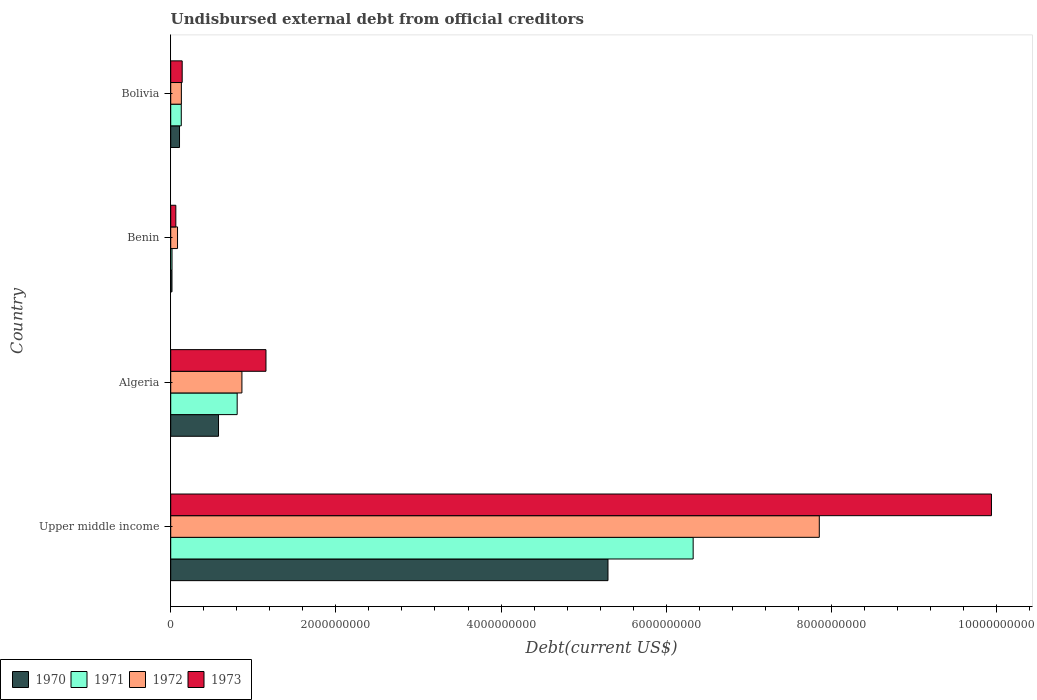Are the number of bars per tick equal to the number of legend labels?
Give a very brief answer. Yes. How many bars are there on the 4th tick from the top?
Provide a succinct answer. 4. How many bars are there on the 3rd tick from the bottom?
Offer a very short reply. 4. What is the total debt in 1973 in Benin?
Keep it short and to the point. 6.20e+07. Across all countries, what is the maximum total debt in 1970?
Provide a succinct answer. 5.30e+09. Across all countries, what is the minimum total debt in 1973?
Keep it short and to the point. 6.20e+07. In which country was the total debt in 1970 maximum?
Your answer should be very brief. Upper middle income. In which country was the total debt in 1972 minimum?
Provide a short and direct response. Benin. What is the total total debt in 1971 in the graph?
Your answer should be very brief. 7.28e+09. What is the difference between the total debt in 1971 in Benin and that in Bolivia?
Make the answer very short. -1.12e+08. What is the difference between the total debt in 1971 in Benin and the total debt in 1972 in Upper middle income?
Your answer should be very brief. -7.84e+09. What is the average total debt in 1972 per country?
Give a very brief answer. 2.23e+09. What is the difference between the total debt in 1971 and total debt in 1972 in Upper middle income?
Your answer should be very brief. -1.53e+09. What is the ratio of the total debt in 1973 in Algeria to that in Benin?
Provide a succinct answer. 18.61. Is the total debt in 1973 in Algeria less than that in Benin?
Provide a succinct answer. No. Is the difference between the total debt in 1971 in Benin and Bolivia greater than the difference between the total debt in 1972 in Benin and Bolivia?
Provide a short and direct response. No. What is the difference between the highest and the second highest total debt in 1973?
Your response must be concise. 8.79e+09. What is the difference between the highest and the lowest total debt in 1973?
Make the answer very short. 9.88e+09. What does the 2nd bar from the top in Bolivia represents?
Ensure brevity in your answer.  1972. What does the 2nd bar from the bottom in Benin represents?
Provide a succinct answer. 1971. Are all the bars in the graph horizontal?
Offer a terse response. Yes. Does the graph contain grids?
Keep it short and to the point. No. Where does the legend appear in the graph?
Your answer should be very brief. Bottom left. What is the title of the graph?
Give a very brief answer. Undisbursed external debt from official creditors. What is the label or title of the X-axis?
Offer a terse response. Debt(current US$). What is the Debt(current US$) in 1970 in Upper middle income?
Offer a terse response. 5.30e+09. What is the Debt(current US$) of 1971 in Upper middle income?
Your response must be concise. 6.33e+09. What is the Debt(current US$) in 1972 in Upper middle income?
Ensure brevity in your answer.  7.85e+09. What is the Debt(current US$) in 1973 in Upper middle income?
Make the answer very short. 9.94e+09. What is the Debt(current US$) of 1970 in Algeria?
Provide a short and direct response. 5.79e+08. What is the Debt(current US$) in 1971 in Algeria?
Your answer should be compact. 8.05e+08. What is the Debt(current US$) of 1972 in Algeria?
Make the answer very short. 8.62e+08. What is the Debt(current US$) in 1973 in Algeria?
Make the answer very short. 1.15e+09. What is the Debt(current US$) of 1970 in Benin?
Your response must be concise. 1.53e+07. What is the Debt(current US$) of 1971 in Benin?
Your answer should be very brief. 1.57e+07. What is the Debt(current US$) of 1972 in Benin?
Offer a terse response. 8.25e+07. What is the Debt(current US$) in 1973 in Benin?
Your answer should be compact. 6.20e+07. What is the Debt(current US$) of 1970 in Bolivia?
Your answer should be very brief. 1.07e+08. What is the Debt(current US$) of 1971 in Bolivia?
Keep it short and to the point. 1.28e+08. What is the Debt(current US$) in 1972 in Bolivia?
Your answer should be very brief. 1.29e+08. What is the Debt(current US$) in 1973 in Bolivia?
Your response must be concise. 1.39e+08. Across all countries, what is the maximum Debt(current US$) of 1970?
Make the answer very short. 5.30e+09. Across all countries, what is the maximum Debt(current US$) of 1971?
Your answer should be very brief. 6.33e+09. Across all countries, what is the maximum Debt(current US$) in 1972?
Offer a terse response. 7.85e+09. Across all countries, what is the maximum Debt(current US$) in 1973?
Offer a very short reply. 9.94e+09. Across all countries, what is the minimum Debt(current US$) in 1970?
Give a very brief answer. 1.53e+07. Across all countries, what is the minimum Debt(current US$) in 1971?
Your answer should be very brief. 1.57e+07. Across all countries, what is the minimum Debt(current US$) in 1972?
Your response must be concise. 8.25e+07. Across all countries, what is the minimum Debt(current US$) in 1973?
Provide a succinct answer. 6.20e+07. What is the total Debt(current US$) of 1970 in the graph?
Offer a very short reply. 6.00e+09. What is the total Debt(current US$) in 1971 in the graph?
Ensure brevity in your answer.  7.28e+09. What is the total Debt(current US$) of 1972 in the graph?
Provide a succinct answer. 8.93e+09. What is the total Debt(current US$) of 1973 in the graph?
Ensure brevity in your answer.  1.13e+1. What is the difference between the Debt(current US$) in 1970 in Upper middle income and that in Algeria?
Your response must be concise. 4.72e+09. What is the difference between the Debt(current US$) in 1971 in Upper middle income and that in Algeria?
Provide a short and direct response. 5.52e+09. What is the difference between the Debt(current US$) of 1972 in Upper middle income and that in Algeria?
Give a very brief answer. 6.99e+09. What is the difference between the Debt(current US$) of 1973 in Upper middle income and that in Algeria?
Provide a succinct answer. 8.79e+09. What is the difference between the Debt(current US$) of 1970 in Upper middle income and that in Benin?
Give a very brief answer. 5.28e+09. What is the difference between the Debt(current US$) in 1971 in Upper middle income and that in Benin?
Your answer should be compact. 6.31e+09. What is the difference between the Debt(current US$) in 1972 in Upper middle income and that in Benin?
Your answer should be compact. 7.77e+09. What is the difference between the Debt(current US$) of 1973 in Upper middle income and that in Benin?
Provide a succinct answer. 9.88e+09. What is the difference between the Debt(current US$) of 1970 in Upper middle income and that in Bolivia?
Your response must be concise. 5.19e+09. What is the difference between the Debt(current US$) in 1971 in Upper middle income and that in Bolivia?
Your response must be concise. 6.20e+09. What is the difference between the Debt(current US$) in 1972 in Upper middle income and that in Bolivia?
Provide a succinct answer. 7.73e+09. What is the difference between the Debt(current US$) in 1973 in Upper middle income and that in Bolivia?
Keep it short and to the point. 9.80e+09. What is the difference between the Debt(current US$) in 1970 in Algeria and that in Benin?
Provide a succinct answer. 5.64e+08. What is the difference between the Debt(current US$) of 1971 in Algeria and that in Benin?
Your answer should be compact. 7.89e+08. What is the difference between the Debt(current US$) in 1972 in Algeria and that in Benin?
Provide a succinct answer. 7.80e+08. What is the difference between the Debt(current US$) in 1973 in Algeria and that in Benin?
Offer a very short reply. 1.09e+09. What is the difference between the Debt(current US$) in 1970 in Algeria and that in Bolivia?
Your answer should be compact. 4.72e+08. What is the difference between the Debt(current US$) of 1971 in Algeria and that in Bolivia?
Keep it short and to the point. 6.77e+08. What is the difference between the Debt(current US$) of 1972 in Algeria and that in Bolivia?
Your answer should be compact. 7.33e+08. What is the difference between the Debt(current US$) in 1973 in Algeria and that in Bolivia?
Ensure brevity in your answer.  1.01e+09. What is the difference between the Debt(current US$) in 1970 in Benin and that in Bolivia?
Your response must be concise. -9.12e+07. What is the difference between the Debt(current US$) in 1971 in Benin and that in Bolivia?
Ensure brevity in your answer.  -1.12e+08. What is the difference between the Debt(current US$) in 1972 in Benin and that in Bolivia?
Offer a terse response. -4.66e+07. What is the difference between the Debt(current US$) in 1973 in Benin and that in Bolivia?
Give a very brief answer. -7.69e+07. What is the difference between the Debt(current US$) in 1970 in Upper middle income and the Debt(current US$) in 1971 in Algeria?
Your answer should be compact. 4.49e+09. What is the difference between the Debt(current US$) of 1970 in Upper middle income and the Debt(current US$) of 1972 in Algeria?
Your answer should be very brief. 4.43e+09. What is the difference between the Debt(current US$) in 1970 in Upper middle income and the Debt(current US$) in 1973 in Algeria?
Give a very brief answer. 4.14e+09. What is the difference between the Debt(current US$) in 1971 in Upper middle income and the Debt(current US$) in 1972 in Algeria?
Your answer should be very brief. 5.46e+09. What is the difference between the Debt(current US$) in 1971 in Upper middle income and the Debt(current US$) in 1973 in Algeria?
Provide a succinct answer. 5.17e+09. What is the difference between the Debt(current US$) in 1972 in Upper middle income and the Debt(current US$) in 1973 in Algeria?
Make the answer very short. 6.70e+09. What is the difference between the Debt(current US$) in 1970 in Upper middle income and the Debt(current US$) in 1971 in Benin?
Make the answer very short. 5.28e+09. What is the difference between the Debt(current US$) in 1970 in Upper middle income and the Debt(current US$) in 1972 in Benin?
Offer a terse response. 5.21e+09. What is the difference between the Debt(current US$) of 1970 in Upper middle income and the Debt(current US$) of 1973 in Benin?
Ensure brevity in your answer.  5.23e+09. What is the difference between the Debt(current US$) of 1971 in Upper middle income and the Debt(current US$) of 1972 in Benin?
Give a very brief answer. 6.24e+09. What is the difference between the Debt(current US$) in 1971 in Upper middle income and the Debt(current US$) in 1973 in Benin?
Offer a terse response. 6.26e+09. What is the difference between the Debt(current US$) in 1972 in Upper middle income and the Debt(current US$) in 1973 in Benin?
Provide a succinct answer. 7.79e+09. What is the difference between the Debt(current US$) of 1970 in Upper middle income and the Debt(current US$) of 1971 in Bolivia?
Provide a short and direct response. 5.17e+09. What is the difference between the Debt(current US$) in 1970 in Upper middle income and the Debt(current US$) in 1972 in Bolivia?
Give a very brief answer. 5.17e+09. What is the difference between the Debt(current US$) of 1970 in Upper middle income and the Debt(current US$) of 1973 in Bolivia?
Provide a succinct answer. 5.16e+09. What is the difference between the Debt(current US$) of 1971 in Upper middle income and the Debt(current US$) of 1972 in Bolivia?
Make the answer very short. 6.20e+09. What is the difference between the Debt(current US$) of 1971 in Upper middle income and the Debt(current US$) of 1973 in Bolivia?
Give a very brief answer. 6.19e+09. What is the difference between the Debt(current US$) in 1972 in Upper middle income and the Debt(current US$) in 1973 in Bolivia?
Offer a very short reply. 7.72e+09. What is the difference between the Debt(current US$) of 1970 in Algeria and the Debt(current US$) of 1971 in Benin?
Offer a terse response. 5.63e+08. What is the difference between the Debt(current US$) of 1970 in Algeria and the Debt(current US$) of 1972 in Benin?
Your answer should be very brief. 4.96e+08. What is the difference between the Debt(current US$) in 1970 in Algeria and the Debt(current US$) in 1973 in Benin?
Provide a short and direct response. 5.17e+08. What is the difference between the Debt(current US$) in 1971 in Algeria and the Debt(current US$) in 1972 in Benin?
Provide a succinct answer. 7.22e+08. What is the difference between the Debt(current US$) of 1971 in Algeria and the Debt(current US$) of 1973 in Benin?
Your answer should be very brief. 7.43e+08. What is the difference between the Debt(current US$) of 1972 in Algeria and the Debt(current US$) of 1973 in Benin?
Provide a short and direct response. 8.00e+08. What is the difference between the Debt(current US$) in 1970 in Algeria and the Debt(current US$) in 1971 in Bolivia?
Provide a short and direct response. 4.51e+08. What is the difference between the Debt(current US$) in 1970 in Algeria and the Debt(current US$) in 1972 in Bolivia?
Provide a short and direct response. 4.50e+08. What is the difference between the Debt(current US$) in 1970 in Algeria and the Debt(current US$) in 1973 in Bolivia?
Offer a very short reply. 4.40e+08. What is the difference between the Debt(current US$) of 1971 in Algeria and the Debt(current US$) of 1972 in Bolivia?
Offer a very short reply. 6.76e+08. What is the difference between the Debt(current US$) in 1971 in Algeria and the Debt(current US$) in 1973 in Bolivia?
Your response must be concise. 6.66e+08. What is the difference between the Debt(current US$) of 1972 in Algeria and the Debt(current US$) of 1973 in Bolivia?
Keep it short and to the point. 7.23e+08. What is the difference between the Debt(current US$) in 1970 in Benin and the Debt(current US$) in 1971 in Bolivia?
Keep it short and to the point. -1.13e+08. What is the difference between the Debt(current US$) of 1970 in Benin and the Debt(current US$) of 1972 in Bolivia?
Offer a terse response. -1.14e+08. What is the difference between the Debt(current US$) of 1970 in Benin and the Debt(current US$) of 1973 in Bolivia?
Provide a short and direct response. -1.24e+08. What is the difference between the Debt(current US$) of 1971 in Benin and the Debt(current US$) of 1972 in Bolivia?
Provide a short and direct response. -1.13e+08. What is the difference between the Debt(current US$) in 1971 in Benin and the Debt(current US$) in 1973 in Bolivia?
Offer a very short reply. -1.23e+08. What is the difference between the Debt(current US$) of 1972 in Benin and the Debt(current US$) of 1973 in Bolivia?
Your answer should be compact. -5.64e+07. What is the average Debt(current US$) in 1970 per country?
Offer a very short reply. 1.50e+09. What is the average Debt(current US$) of 1971 per country?
Make the answer very short. 1.82e+09. What is the average Debt(current US$) of 1972 per country?
Give a very brief answer. 2.23e+09. What is the average Debt(current US$) of 1973 per country?
Keep it short and to the point. 2.82e+09. What is the difference between the Debt(current US$) of 1970 and Debt(current US$) of 1971 in Upper middle income?
Provide a succinct answer. -1.03e+09. What is the difference between the Debt(current US$) in 1970 and Debt(current US$) in 1972 in Upper middle income?
Provide a short and direct response. -2.56e+09. What is the difference between the Debt(current US$) of 1970 and Debt(current US$) of 1973 in Upper middle income?
Give a very brief answer. -4.64e+09. What is the difference between the Debt(current US$) in 1971 and Debt(current US$) in 1972 in Upper middle income?
Ensure brevity in your answer.  -1.53e+09. What is the difference between the Debt(current US$) of 1971 and Debt(current US$) of 1973 in Upper middle income?
Give a very brief answer. -3.61e+09. What is the difference between the Debt(current US$) in 1972 and Debt(current US$) in 1973 in Upper middle income?
Make the answer very short. -2.08e+09. What is the difference between the Debt(current US$) in 1970 and Debt(current US$) in 1971 in Algeria?
Ensure brevity in your answer.  -2.26e+08. What is the difference between the Debt(current US$) of 1970 and Debt(current US$) of 1972 in Algeria?
Provide a succinct answer. -2.83e+08. What is the difference between the Debt(current US$) of 1970 and Debt(current US$) of 1973 in Algeria?
Provide a short and direct response. -5.75e+08. What is the difference between the Debt(current US$) in 1971 and Debt(current US$) in 1972 in Algeria?
Ensure brevity in your answer.  -5.74e+07. What is the difference between the Debt(current US$) in 1971 and Debt(current US$) in 1973 in Algeria?
Your response must be concise. -3.49e+08. What is the difference between the Debt(current US$) of 1972 and Debt(current US$) of 1973 in Algeria?
Your response must be concise. -2.91e+08. What is the difference between the Debt(current US$) in 1970 and Debt(current US$) in 1971 in Benin?
Your answer should be very brief. -3.83e+05. What is the difference between the Debt(current US$) in 1970 and Debt(current US$) in 1972 in Benin?
Give a very brief answer. -6.72e+07. What is the difference between the Debt(current US$) in 1970 and Debt(current US$) in 1973 in Benin?
Your answer should be compact. -4.67e+07. What is the difference between the Debt(current US$) of 1971 and Debt(current US$) of 1972 in Benin?
Your answer should be very brief. -6.68e+07. What is the difference between the Debt(current US$) in 1971 and Debt(current US$) in 1973 in Benin?
Provide a succinct answer. -4.63e+07. What is the difference between the Debt(current US$) of 1972 and Debt(current US$) of 1973 in Benin?
Ensure brevity in your answer.  2.05e+07. What is the difference between the Debt(current US$) in 1970 and Debt(current US$) in 1971 in Bolivia?
Make the answer very short. -2.14e+07. What is the difference between the Debt(current US$) of 1970 and Debt(current US$) of 1972 in Bolivia?
Your answer should be very brief. -2.26e+07. What is the difference between the Debt(current US$) in 1970 and Debt(current US$) in 1973 in Bolivia?
Make the answer very short. -3.24e+07. What is the difference between the Debt(current US$) in 1971 and Debt(current US$) in 1972 in Bolivia?
Offer a terse response. -1.17e+06. What is the difference between the Debt(current US$) of 1971 and Debt(current US$) of 1973 in Bolivia?
Ensure brevity in your answer.  -1.10e+07. What is the difference between the Debt(current US$) in 1972 and Debt(current US$) in 1973 in Bolivia?
Your answer should be very brief. -9.80e+06. What is the ratio of the Debt(current US$) of 1970 in Upper middle income to that in Algeria?
Your answer should be very brief. 9.15. What is the ratio of the Debt(current US$) in 1971 in Upper middle income to that in Algeria?
Give a very brief answer. 7.86. What is the ratio of the Debt(current US$) of 1972 in Upper middle income to that in Algeria?
Keep it short and to the point. 9.11. What is the ratio of the Debt(current US$) in 1973 in Upper middle income to that in Algeria?
Provide a short and direct response. 8.62. What is the ratio of the Debt(current US$) of 1970 in Upper middle income to that in Benin?
Your response must be concise. 346.37. What is the ratio of the Debt(current US$) of 1971 in Upper middle income to that in Benin?
Your answer should be very brief. 403.72. What is the ratio of the Debt(current US$) of 1972 in Upper middle income to that in Benin?
Your response must be concise. 95.21. What is the ratio of the Debt(current US$) of 1973 in Upper middle income to that in Benin?
Offer a very short reply. 160.36. What is the ratio of the Debt(current US$) in 1970 in Upper middle income to that in Bolivia?
Provide a succinct answer. 49.71. What is the ratio of the Debt(current US$) of 1971 in Upper middle income to that in Bolivia?
Make the answer very short. 49.45. What is the ratio of the Debt(current US$) of 1972 in Upper middle income to that in Bolivia?
Your answer should be very brief. 60.83. What is the ratio of the Debt(current US$) of 1973 in Upper middle income to that in Bolivia?
Your response must be concise. 71.55. What is the ratio of the Debt(current US$) of 1970 in Algeria to that in Benin?
Your answer should be very brief. 37.87. What is the ratio of the Debt(current US$) in 1971 in Algeria to that in Benin?
Your response must be concise. 51.36. What is the ratio of the Debt(current US$) of 1972 in Algeria to that in Benin?
Give a very brief answer. 10.45. What is the ratio of the Debt(current US$) of 1973 in Algeria to that in Benin?
Offer a very short reply. 18.61. What is the ratio of the Debt(current US$) in 1970 in Algeria to that in Bolivia?
Give a very brief answer. 5.43. What is the ratio of the Debt(current US$) of 1971 in Algeria to that in Bolivia?
Ensure brevity in your answer.  6.29. What is the ratio of the Debt(current US$) in 1972 in Algeria to that in Bolivia?
Make the answer very short. 6.68. What is the ratio of the Debt(current US$) of 1973 in Algeria to that in Bolivia?
Keep it short and to the point. 8.3. What is the ratio of the Debt(current US$) in 1970 in Benin to that in Bolivia?
Keep it short and to the point. 0.14. What is the ratio of the Debt(current US$) in 1971 in Benin to that in Bolivia?
Keep it short and to the point. 0.12. What is the ratio of the Debt(current US$) in 1972 in Benin to that in Bolivia?
Keep it short and to the point. 0.64. What is the ratio of the Debt(current US$) of 1973 in Benin to that in Bolivia?
Your answer should be compact. 0.45. What is the difference between the highest and the second highest Debt(current US$) in 1970?
Offer a terse response. 4.72e+09. What is the difference between the highest and the second highest Debt(current US$) in 1971?
Ensure brevity in your answer.  5.52e+09. What is the difference between the highest and the second highest Debt(current US$) of 1972?
Give a very brief answer. 6.99e+09. What is the difference between the highest and the second highest Debt(current US$) in 1973?
Keep it short and to the point. 8.79e+09. What is the difference between the highest and the lowest Debt(current US$) in 1970?
Give a very brief answer. 5.28e+09. What is the difference between the highest and the lowest Debt(current US$) of 1971?
Give a very brief answer. 6.31e+09. What is the difference between the highest and the lowest Debt(current US$) of 1972?
Offer a terse response. 7.77e+09. What is the difference between the highest and the lowest Debt(current US$) in 1973?
Your response must be concise. 9.88e+09. 